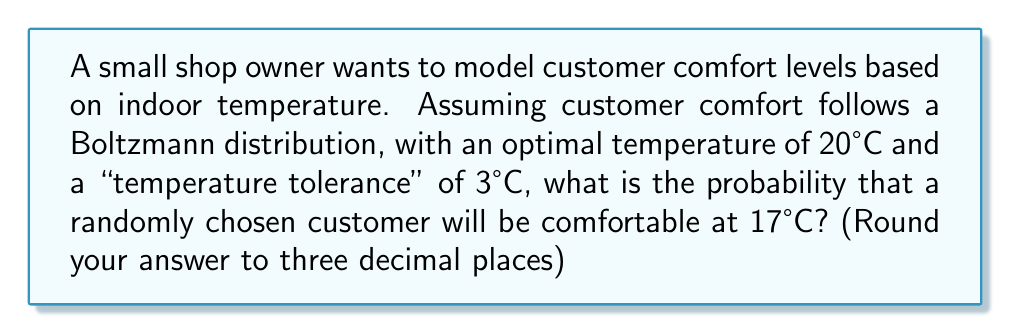Can you solve this math problem? Let's approach this step-by-step using the Boltzmann distribution from statistical mechanics:

1) The Boltzmann distribution is given by:

   $$P(E) = \frac{1}{Z} e^{-\frac{E}{kT}}$$

   where $P(E)$ is the probability, $E$ is the energy state, $k$ is Boltzmann's constant, and $T$ is temperature.

2) In our case, we can model the comfort level as an energy state, where the deviation from the optimal temperature represents the energy:

   $$E = (T - T_{optimal})^2$$

3) The "temperature tolerance" can be seen as analogous to $kT$ in the original equation. Let's call this $\sigma^2$. Our equation becomes:

   $$P(T) = \frac{1}{Z} e^{-\frac{(T-T_{optimal})^2}{2\sigma^2}}$$

4) We're given:
   $T_{optimal} = 20°C$
   $\sigma = 3°C$
   $T = 17°C$

5) Substituting these values:

   $$P(17) = \frac{1}{Z} e^{-\frac{(17-20)^2}{2(3^2)}}$$

6) Simplify:
   $$P(17) = \frac{1}{Z} e^{-\frac{9}{18}} = \frac{1}{Z} e^{-0.5}$$

7) The normalization factor $Z$ ensures that all probabilities sum to 1. For our purposes, we can consider comfort as a binary state (comfortable or not), so we can approximate $Z$ as:

   $$Z \approx e^{-0.5} + e^{0} = e^{-0.5} + 1$$

8) Therefore:

   $$P(17) = \frac{e^{-0.5}}{e^{-0.5} + 1} \approx 0.378$$

Rounding to three decimal places gives us 0.378.
Answer: 0.378 